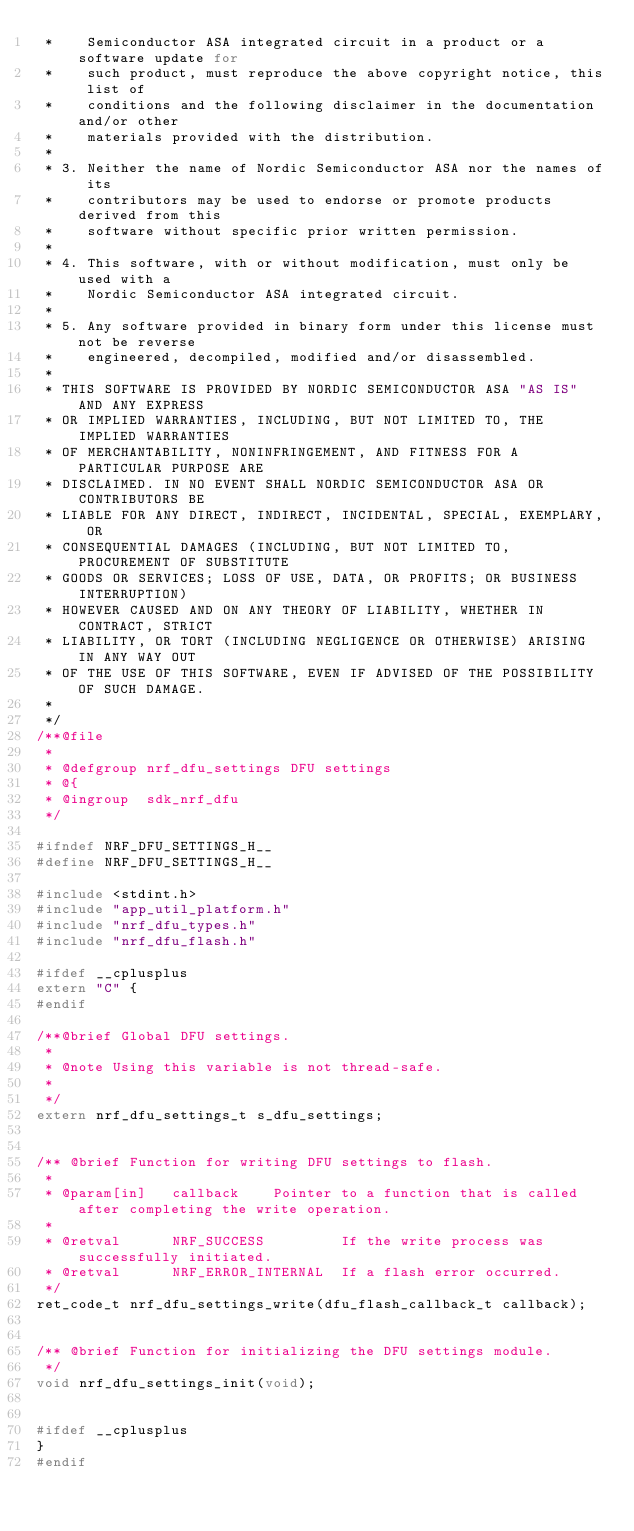<code> <loc_0><loc_0><loc_500><loc_500><_C_> *    Semiconductor ASA integrated circuit in a product or a software update for
 *    such product, must reproduce the above copyright notice, this list of
 *    conditions and the following disclaimer in the documentation and/or other
 *    materials provided with the distribution.
 * 
 * 3. Neither the name of Nordic Semiconductor ASA nor the names of its
 *    contributors may be used to endorse or promote products derived from this
 *    software without specific prior written permission.
 * 
 * 4. This software, with or without modification, must only be used with a
 *    Nordic Semiconductor ASA integrated circuit.
 * 
 * 5. Any software provided in binary form under this license must not be reverse
 *    engineered, decompiled, modified and/or disassembled.
 * 
 * THIS SOFTWARE IS PROVIDED BY NORDIC SEMICONDUCTOR ASA "AS IS" AND ANY EXPRESS
 * OR IMPLIED WARRANTIES, INCLUDING, BUT NOT LIMITED TO, THE IMPLIED WARRANTIES
 * OF MERCHANTABILITY, NONINFRINGEMENT, AND FITNESS FOR A PARTICULAR PURPOSE ARE
 * DISCLAIMED. IN NO EVENT SHALL NORDIC SEMICONDUCTOR ASA OR CONTRIBUTORS BE
 * LIABLE FOR ANY DIRECT, INDIRECT, INCIDENTAL, SPECIAL, EXEMPLARY, OR
 * CONSEQUENTIAL DAMAGES (INCLUDING, BUT NOT LIMITED TO, PROCUREMENT OF SUBSTITUTE
 * GOODS OR SERVICES; LOSS OF USE, DATA, OR PROFITS; OR BUSINESS INTERRUPTION)
 * HOWEVER CAUSED AND ON ANY THEORY OF LIABILITY, WHETHER IN CONTRACT, STRICT
 * LIABILITY, OR TORT (INCLUDING NEGLIGENCE OR OTHERWISE) ARISING IN ANY WAY OUT
 * OF THE USE OF THIS SOFTWARE, EVEN IF ADVISED OF THE POSSIBILITY OF SUCH DAMAGE.
 * 
 */
/**@file
 *
 * @defgroup nrf_dfu_settings DFU settings
 * @{
 * @ingroup  sdk_nrf_dfu
 */

#ifndef NRF_DFU_SETTINGS_H__
#define NRF_DFU_SETTINGS_H__

#include <stdint.h>
#include "app_util_platform.h"
#include "nrf_dfu_types.h"
#include "nrf_dfu_flash.h"

#ifdef __cplusplus
extern "C" {
#endif

/**@brief Global DFU settings.
 *
 * @note Using this variable is not thread-safe.
 *
 */
extern nrf_dfu_settings_t s_dfu_settings;


/** @brief Function for writing DFU settings to flash.
 *
 * @param[in]   callback    Pointer to a function that is called after completing the write operation.
 *
 * @retval      NRF_SUCCESS         If the write process was successfully initiated.
 * @retval      NRF_ERROR_INTERNAL  If a flash error occurred.
 */
ret_code_t nrf_dfu_settings_write(dfu_flash_callback_t callback);


/** @brief Function for initializing the DFU settings module.
 */
void nrf_dfu_settings_init(void);


#ifdef __cplusplus
}
#endif
</code> 